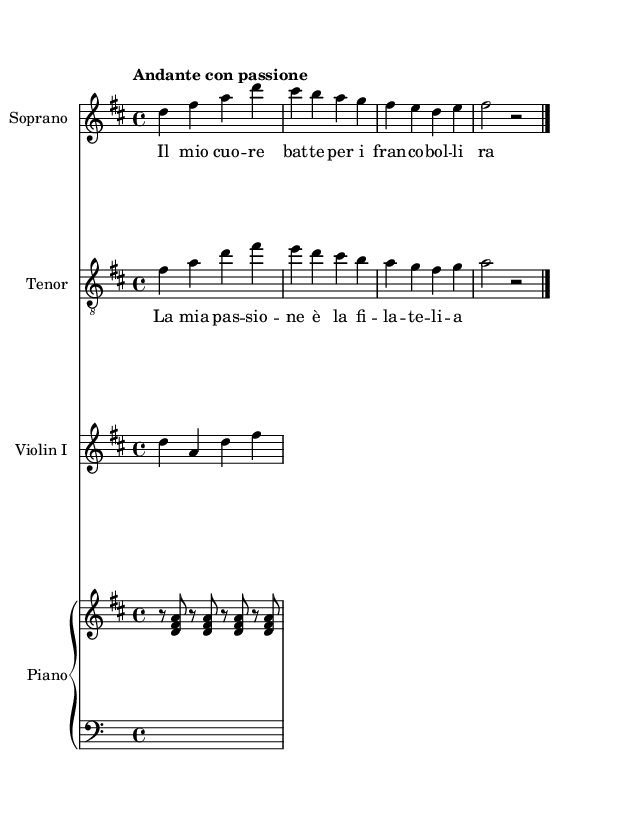What is the key signature of this music? The key signature is identified by looking at the beginning of the staff where the sharp or flat symbols are placed. The music has two sharps, indicating that it is in D major.
Answer: D major What is the time signature of this music? The time signature is located right after the key signature at the beginning of the staff. It shows that there are four beats in each measure, indicated by the "4/4" symbol.
Answer: 4/4 What is the tempo marking in this music? The tempo marking is typically written above the staff, indicating the speed of the piece. Here, it states "Andante con passione," which suggests a moderate and expressive pace.
Answer: Andante con passione How many vocal parts are present in this score? The score includes two vocal parts: soprano and tenor. This information can be found at the top of their respective staff labels.
Answer: Two Which instrument is playing the melody in the first four measures? By examining the notation in the first four measures, it's clear that the soprano part plays the melody, as it consists of a higher range of notes compared to other parts.
Answer: Soprano What are the lyrics sung by the soprano? The lyrics are indicated below the soprano staff, which shows the text corresponding to the notes sung. The lyrics read "Il mio cuo -- re bat -- te per i fran -- co -- bol -- li ra -- ri."
Answer: Il mio cuore batte per i francobolli rari What is the relationship of the tenor melody to the soprano melody in terms of harmony? The tenor melody harmonizes with the soprano by providing a compatible and sometimes contrasting range of pitches that fill in intervals and create depth in the music. It is often in a lower range than the soprano.
Answer: Harmonizing 